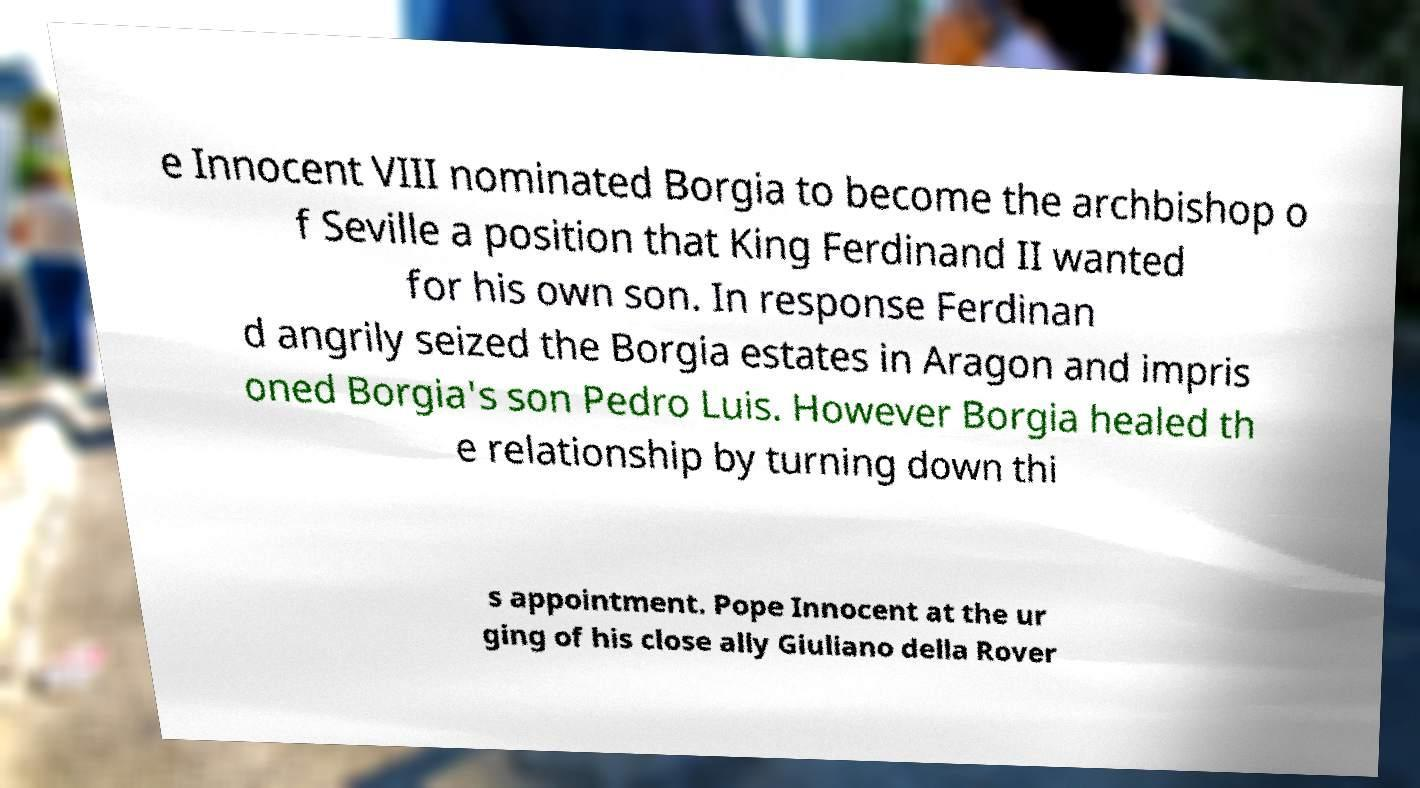Could you extract and type out the text from this image? e Innocent VIII nominated Borgia to become the archbishop o f Seville a position that King Ferdinand II wanted for his own son. In response Ferdinan d angrily seized the Borgia estates in Aragon and impris oned Borgia's son Pedro Luis. However Borgia healed th e relationship by turning down thi s appointment. Pope Innocent at the ur ging of his close ally Giuliano della Rover 